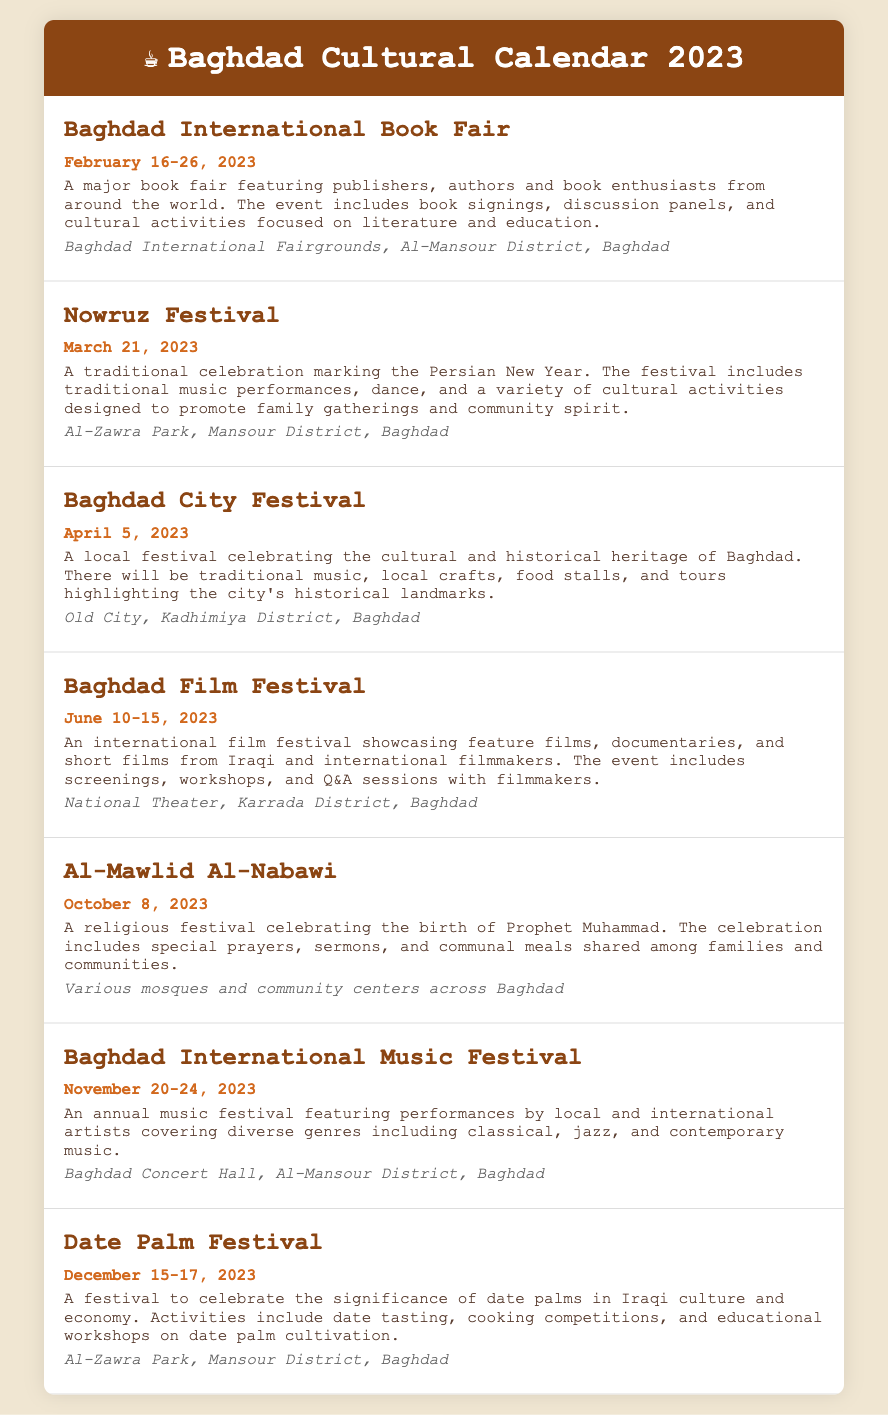What is the date of the Baghdad International Book Fair? The Baghdad International Book Fair is held from February 16 to February 26, 2023.
Answer: February 16-26, 2023 Where will the Nowruz Festival take place? The Nowruz Festival will occur at Al-Zawra Park in the Mansour District of Baghdad.
Answer: Al-Zawra Park, Mansour District, Baghdad How long does the Baghdad Film Festival last? The Baghdad Film Festival runs for six days, from June 10 to June 15, 2023.
Answer: 6 days What type of event is Al-Mawlid Al-Nabawi? Al-Mawlid Al-Nabawi is a religious festival celebrating the birth of Prophet Muhammad.
Answer: Religious festival What activities are part of the Date Palm Festival? The Date Palm Festival includes date tasting, cooking competitions, and educational workshops on date palm cultivation.
Answer: Date tasting, cooking competitions, educational workshops Which event occurs in November? The Baghdad International Music Festival is scheduled for November 20-24, 2023.
Answer: Baghdad International Music Festival What will be highlighted in the Baghdad City Festival? The Baghdad City Festival will highlight the cultural and historical heritage of Baghdad.
Answer: Cultural and historical heritage In which district is the Baghdad Concert Hall located? The Baghdad Concert Hall is located in the Al-Mansour District of Baghdad.
Answer: Al-Mansour District 